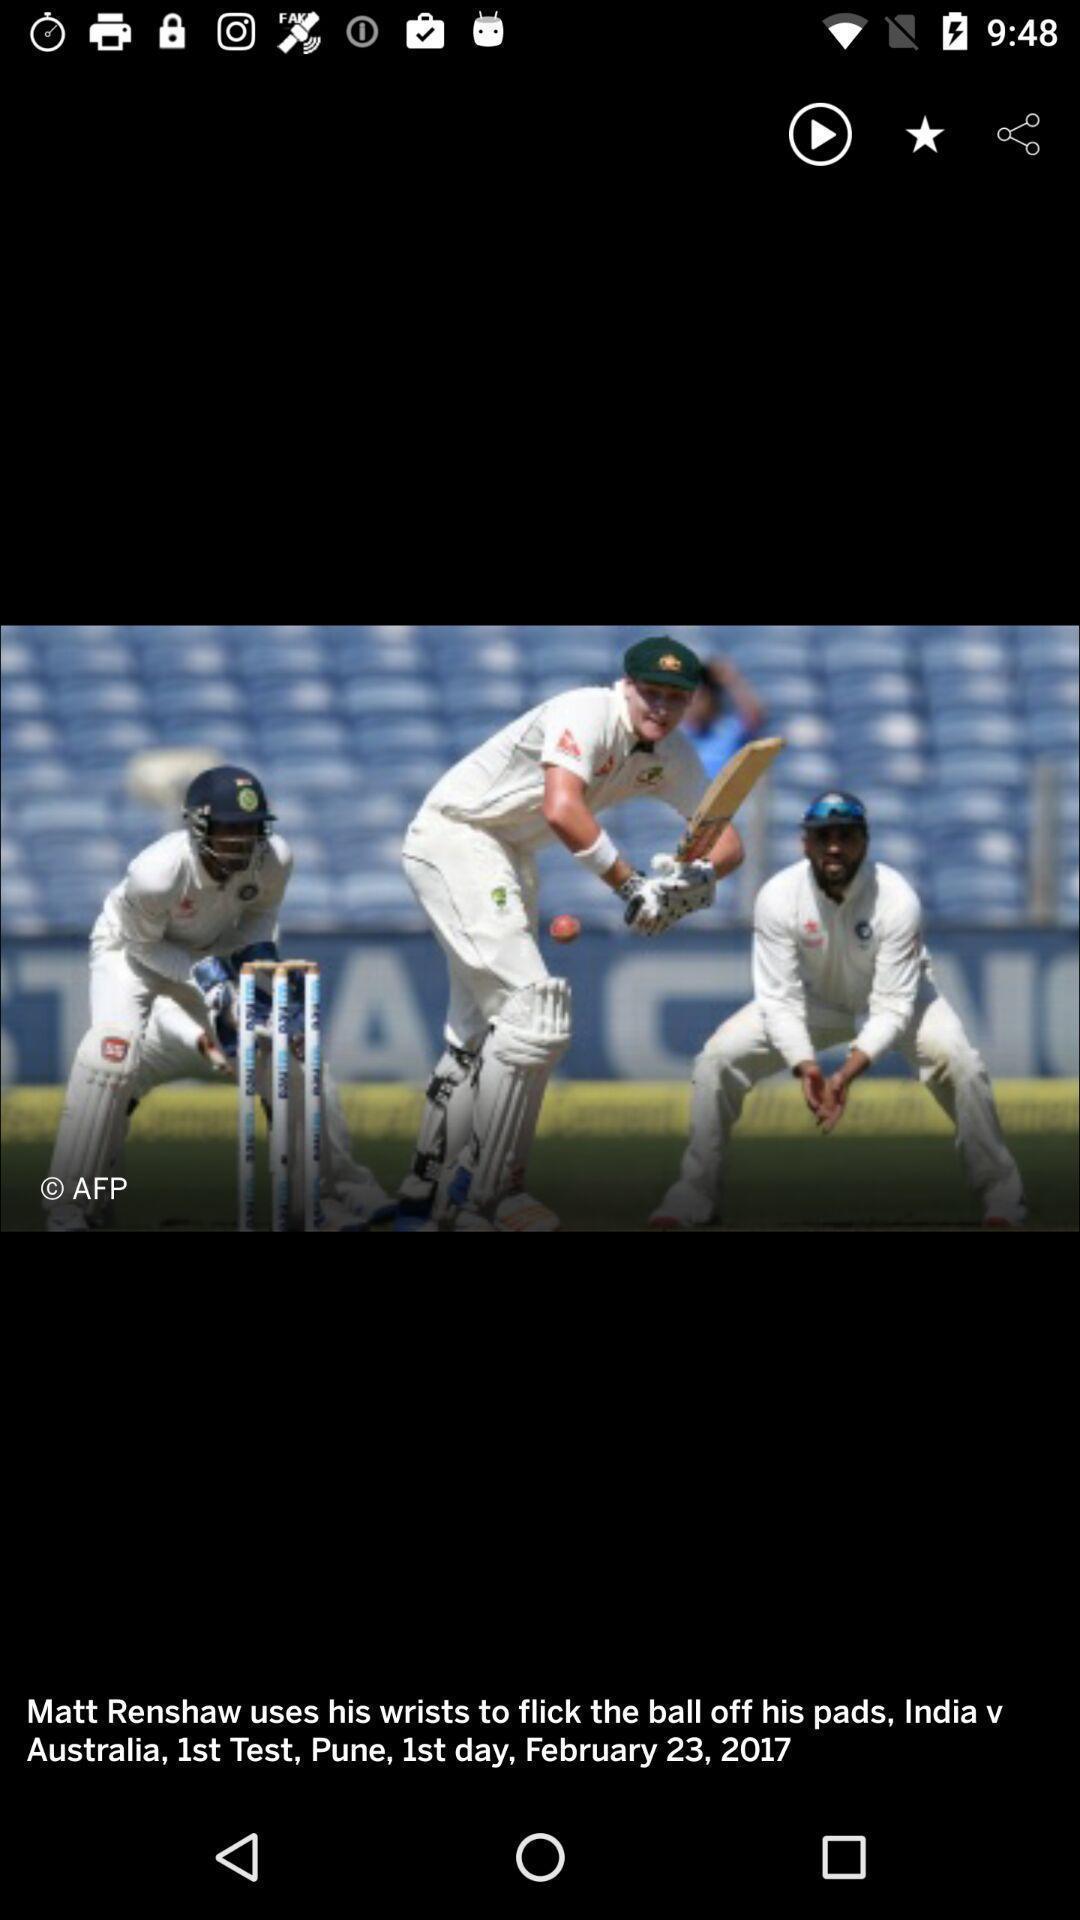Please provide a description for this image. Screen displaying an image with description and multiple control options. 